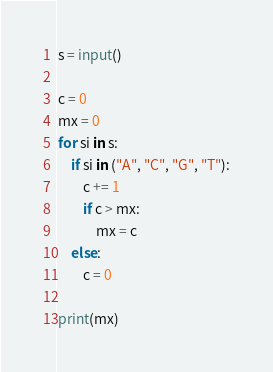Convert code to text. <code><loc_0><loc_0><loc_500><loc_500><_Python_>s = input()

c = 0
mx = 0
for si in s:
    if si in ("A", "C", "G", "T"):
        c += 1
        if c > mx:
            mx = c
    else:
        c = 0

print(mx)
</code> 